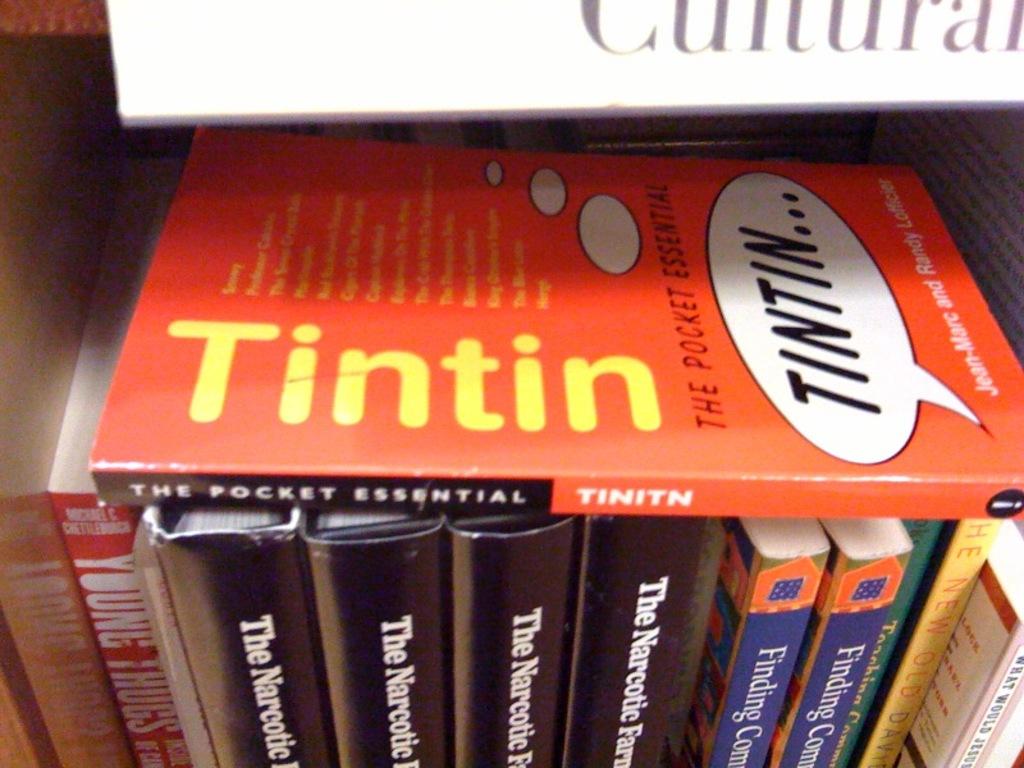What is the title of the red book?
Offer a very short reply. Tintin. What is the first world on all the black books?
Provide a short and direct response. The. 